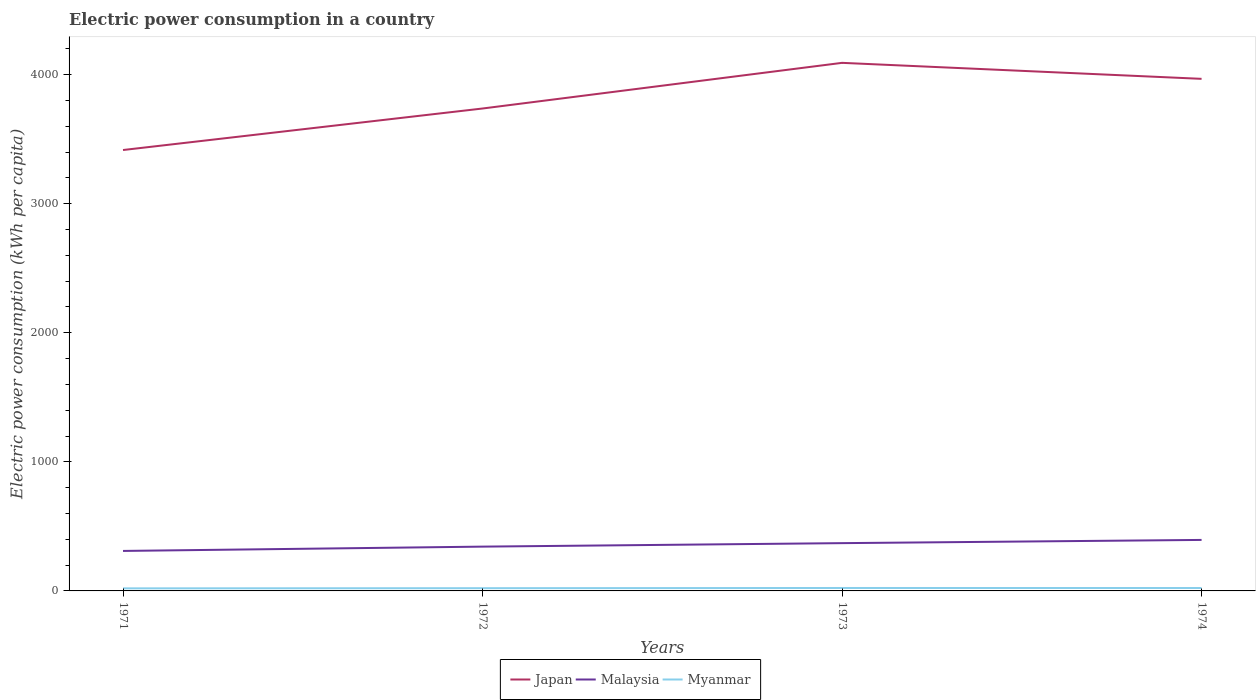How many different coloured lines are there?
Ensure brevity in your answer.  3. Is the number of lines equal to the number of legend labels?
Provide a short and direct response. Yes. Across all years, what is the maximum electric power consumption in in Japan?
Provide a short and direct response. 3415.69. What is the total electric power consumption in in Malaysia in the graph?
Keep it short and to the point. -51.95. What is the difference between the highest and the second highest electric power consumption in in Japan?
Provide a short and direct response. 675.31. What is the difference between the highest and the lowest electric power consumption in in Myanmar?
Your answer should be very brief. 2. How many lines are there?
Keep it short and to the point. 3. How many years are there in the graph?
Offer a very short reply. 4. What is the difference between two consecutive major ticks on the Y-axis?
Keep it short and to the point. 1000. Are the values on the major ticks of Y-axis written in scientific E-notation?
Ensure brevity in your answer.  No. Does the graph contain any zero values?
Your answer should be compact. No. How are the legend labels stacked?
Offer a terse response. Horizontal. What is the title of the graph?
Give a very brief answer. Electric power consumption in a country. Does "Mexico" appear as one of the legend labels in the graph?
Make the answer very short. No. What is the label or title of the Y-axis?
Ensure brevity in your answer.  Electric power consumption (kWh per capita). What is the Electric power consumption (kWh per capita) in Japan in 1971?
Keep it short and to the point. 3415.69. What is the Electric power consumption (kWh per capita) in Malaysia in 1971?
Ensure brevity in your answer.  309.78. What is the Electric power consumption (kWh per capita) of Myanmar in 1971?
Offer a very short reply. 19.87. What is the Electric power consumption (kWh per capita) of Japan in 1972?
Keep it short and to the point. 3737.27. What is the Electric power consumption (kWh per capita) in Malaysia in 1972?
Give a very brief answer. 343.19. What is the Electric power consumption (kWh per capita) in Myanmar in 1972?
Your answer should be compact. 21.22. What is the Electric power consumption (kWh per capita) in Japan in 1973?
Give a very brief answer. 4091. What is the Electric power consumption (kWh per capita) in Malaysia in 1973?
Keep it short and to the point. 370.21. What is the Electric power consumption (kWh per capita) of Myanmar in 1973?
Your answer should be very brief. 22.8. What is the Electric power consumption (kWh per capita) in Japan in 1974?
Make the answer very short. 3967.08. What is the Electric power consumption (kWh per capita) of Malaysia in 1974?
Make the answer very short. 395.15. What is the Electric power consumption (kWh per capita) in Myanmar in 1974?
Offer a very short reply. 22.46. Across all years, what is the maximum Electric power consumption (kWh per capita) of Japan?
Provide a short and direct response. 4091. Across all years, what is the maximum Electric power consumption (kWh per capita) in Malaysia?
Offer a very short reply. 395.15. Across all years, what is the maximum Electric power consumption (kWh per capita) in Myanmar?
Give a very brief answer. 22.8. Across all years, what is the minimum Electric power consumption (kWh per capita) of Japan?
Your answer should be very brief. 3415.69. Across all years, what is the minimum Electric power consumption (kWh per capita) in Malaysia?
Offer a terse response. 309.78. Across all years, what is the minimum Electric power consumption (kWh per capita) of Myanmar?
Keep it short and to the point. 19.87. What is the total Electric power consumption (kWh per capita) in Japan in the graph?
Your answer should be very brief. 1.52e+04. What is the total Electric power consumption (kWh per capita) of Malaysia in the graph?
Give a very brief answer. 1418.33. What is the total Electric power consumption (kWh per capita) of Myanmar in the graph?
Ensure brevity in your answer.  86.34. What is the difference between the Electric power consumption (kWh per capita) of Japan in 1971 and that in 1972?
Offer a terse response. -321.58. What is the difference between the Electric power consumption (kWh per capita) in Malaysia in 1971 and that in 1972?
Make the answer very short. -33.41. What is the difference between the Electric power consumption (kWh per capita) in Myanmar in 1971 and that in 1972?
Give a very brief answer. -1.35. What is the difference between the Electric power consumption (kWh per capita) in Japan in 1971 and that in 1973?
Offer a terse response. -675.31. What is the difference between the Electric power consumption (kWh per capita) of Malaysia in 1971 and that in 1973?
Ensure brevity in your answer.  -60.43. What is the difference between the Electric power consumption (kWh per capita) in Myanmar in 1971 and that in 1973?
Keep it short and to the point. -2.93. What is the difference between the Electric power consumption (kWh per capita) in Japan in 1971 and that in 1974?
Give a very brief answer. -551.4. What is the difference between the Electric power consumption (kWh per capita) in Malaysia in 1971 and that in 1974?
Your answer should be compact. -85.36. What is the difference between the Electric power consumption (kWh per capita) of Myanmar in 1971 and that in 1974?
Your answer should be very brief. -2.6. What is the difference between the Electric power consumption (kWh per capita) in Japan in 1972 and that in 1973?
Your response must be concise. -353.73. What is the difference between the Electric power consumption (kWh per capita) of Malaysia in 1972 and that in 1973?
Provide a short and direct response. -27.02. What is the difference between the Electric power consumption (kWh per capita) in Myanmar in 1972 and that in 1973?
Keep it short and to the point. -1.59. What is the difference between the Electric power consumption (kWh per capita) in Japan in 1972 and that in 1974?
Provide a short and direct response. -229.82. What is the difference between the Electric power consumption (kWh per capita) of Malaysia in 1972 and that in 1974?
Ensure brevity in your answer.  -51.95. What is the difference between the Electric power consumption (kWh per capita) of Myanmar in 1972 and that in 1974?
Make the answer very short. -1.25. What is the difference between the Electric power consumption (kWh per capita) in Japan in 1973 and that in 1974?
Provide a succinct answer. 123.91. What is the difference between the Electric power consumption (kWh per capita) of Malaysia in 1973 and that in 1974?
Provide a succinct answer. -24.93. What is the difference between the Electric power consumption (kWh per capita) of Myanmar in 1973 and that in 1974?
Your answer should be very brief. 0.34. What is the difference between the Electric power consumption (kWh per capita) of Japan in 1971 and the Electric power consumption (kWh per capita) of Malaysia in 1972?
Keep it short and to the point. 3072.5. What is the difference between the Electric power consumption (kWh per capita) in Japan in 1971 and the Electric power consumption (kWh per capita) in Myanmar in 1972?
Offer a terse response. 3394.47. What is the difference between the Electric power consumption (kWh per capita) of Malaysia in 1971 and the Electric power consumption (kWh per capita) of Myanmar in 1972?
Provide a succinct answer. 288.57. What is the difference between the Electric power consumption (kWh per capita) in Japan in 1971 and the Electric power consumption (kWh per capita) in Malaysia in 1973?
Make the answer very short. 3045.47. What is the difference between the Electric power consumption (kWh per capita) of Japan in 1971 and the Electric power consumption (kWh per capita) of Myanmar in 1973?
Your answer should be very brief. 3392.89. What is the difference between the Electric power consumption (kWh per capita) in Malaysia in 1971 and the Electric power consumption (kWh per capita) in Myanmar in 1973?
Keep it short and to the point. 286.98. What is the difference between the Electric power consumption (kWh per capita) of Japan in 1971 and the Electric power consumption (kWh per capita) of Malaysia in 1974?
Give a very brief answer. 3020.54. What is the difference between the Electric power consumption (kWh per capita) in Japan in 1971 and the Electric power consumption (kWh per capita) in Myanmar in 1974?
Offer a very short reply. 3393.23. What is the difference between the Electric power consumption (kWh per capita) of Malaysia in 1971 and the Electric power consumption (kWh per capita) of Myanmar in 1974?
Your response must be concise. 287.32. What is the difference between the Electric power consumption (kWh per capita) in Japan in 1972 and the Electric power consumption (kWh per capita) in Malaysia in 1973?
Your answer should be very brief. 3367.05. What is the difference between the Electric power consumption (kWh per capita) in Japan in 1972 and the Electric power consumption (kWh per capita) in Myanmar in 1973?
Provide a short and direct response. 3714.46. What is the difference between the Electric power consumption (kWh per capita) in Malaysia in 1972 and the Electric power consumption (kWh per capita) in Myanmar in 1973?
Your response must be concise. 320.39. What is the difference between the Electric power consumption (kWh per capita) of Japan in 1972 and the Electric power consumption (kWh per capita) of Malaysia in 1974?
Keep it short and to the point. 3342.12. What is the difference between the Electric power consumption (kWh per capita) of Japan in 1972 and the Electric power consumption (kWh per capita) of Myanmar in 1974?
Your answer should be compact. 3714.8. What is the difference between the Electric power consumption (kWh per capita) of Malaysia in 1972 and the Electric power consumption (kWh per capita) of Myanmar in 1974?
Your answer should be compact. 320.73. What is the difference between the Electric power consumption (kWh per capita) of Japan in 1973 and the Electric power consumption (kWh per capita) of Malaysia in 1974?
Offer a terse response. 3695.85. What is the difference between the Electric power consumption (kWh per capita) in Japan in 1973 and the Electric power consumption (kWh per capita) in Myanmar in 1974?
Offer a very short reply. 4068.54. What is the difference between the Electric power consumption (kWh per capita) of Malaysia in 1973 and the Electric power consumption (kWh per capita) of Myanmar in 1974?
Provide a short and direct response. 347.75. What is the average Electric power consumption (kWh per capita) of Japan per year?
Ensure brevity in your answer.  3802.76. What is the average Electric power consumption (kWh per capita) in Malaysia per year?
Give a very brief answer. 354.58. What is the average Electric power consumption (kWh per capita) in Myanmar per year?
Offer a very short reply. 21.59. In the year 1971, what is the difference between the Electric power consumption (kWh per capita) of Japan and Electric power consumption (kWh per capita) of Malaysia?
Your answer should be very brief. 3105.91. In the year 1971, what is the difference between the Electric power consumption (kWh per capita) of Japan and Electric power consumption (kWh per capita) of Myanmar?
Provide a succinct answer. 3395.82. In the year 1971, what is the difference between the Electric power consumption (kWh per capita) in Malaysia and Electric power consumption (kWh per capita) in Myanmar?
Keep it short and to the point. 289.92. In the year 1972, what is the difference between the Electric power consumption (kWh per capita) in Japan and Electric power consumption (kWh per capita) in Malaysia?
Offer a terse response. 3394.07. In the year 1972, what is the difference between the Electric power consumption (kWh per capita) in Japan and Electric power consumption (kWh per capita) in Myanmar?
Keep it short and to the point. 3716.05. In the year 1972, what is the difference between the Electric power consumption (kWh per capita) in Malaysia and Electric power consumption (kWh per capita) in Myanmar?
Ensure brevity in your answer.  321.98. In the year 1973, what is the difference between the Electric power consumption (kWh per capita) in Japan and Electric power consumption (kWh per capita) in Malaysia?
Provide a short and direct response. 3720.78. In the year 1973, what is the difference between the Electric power consumption (kWh per capita) of Japan and Electric power consumption (kWh per capita) of Myanmar?
Provide a succinct answer. 4068.2. In the year 1973, what is the difference between the Electric power consumption (kWh per capita) of Malaysia and Electric power consumption (kWh per capita) of Myanmar?
Offer a very short reply. 347.41. In the year 1974, what is the difference between the Electric power consumption (kWh per capita) of Japan and Electric power consumption (kWh per capita) of Malaysia?
Make the answer very short. 3571.94. In the year 1974, what is the difference between the Electric power consumption (kWh per capita) in Japan and Electric power consumption (kWh per capita) in Myanmar?
Offer a very short reply. 3944.62. In the year 1974, what is the difference between the Electric power consumption (kWh per capita) in Malaysia and Electric power consumption (kWh per capita) in Myanmar?
Give a very brief answer. 372.68. What is the ratio of the Electric power consumption (kWh per capita) in Japan in 1971 to that in 1972?
Your answer should be compact. 0.91. What is the ratio of the Electric power consumption (kWh per capita) in Malaysia in 1971 to that in 1972?
Make the answer very short. 0.9. What is the ratio of the Electric power consumption (kWh per capita) of Myanmar in 1971 to that in 1972?
Keep it short and to the point. 0.94. What is the ratio of the Electric power consumption (kWh per capita) in Japan in 1971 to that in 1973?
Your response must be concise. 0.83. What is the ratio of the Electric power consumption (kWh per capita) in Malaysia in 1971 to that in 1973?
Make the answer very short. 0.84. What is the ratio of the Electric power consumption (kWh per capita) in Myanmar in 1971 to that in 1973?
Provide a succinct answer. 0.87. What is the ratio of the Electric power consumption (kWh per capita) in Japan in 1971 to that in 1974?
Your response must be concise. 0.86. What is the ratio of the Electric power consumption (kWh per capita) in Malaysia in 1971 to that in 1974?
Your answer should be very brief. 0.78. What is the ratio of the Electric power consumption (kWh per capita) of Myanmar in 1971 to that in 1974?
Make the answer very short. 0.88. What is the ratio of the Electric power consumption (kWh per capita) in Japan in 1972 to that in 1973?
Make the answer very short. 0.91. What is the ratio of the Electric power consumption (kWh per capita) of Malaysia in 1972 to that in 1973?
Your response must be concise. 0.93. What is the ratio of the Electric power consumption (kWh per capita) in Myanmar in 1972 to that in 1973?
Provide a succinct answer. 0.93. What is the ratio of the Electric power consumption (kWh per capita) of Japan in 1972 to that in 1974?
Provide a succinct answer. 0.94. What is the ratio of the Electric power consumption (kWh per capita) in Malaysia in 1972 to that in 1974?
Your answer should be very brief. 0.87. What is the ratio of the Electric power consumption (kWh per capita) in Myanmar in 1972 to that in 1974?
Offer a terse response. 0.94. What is the ratio of the Electric power consumption (kWh per capita) in Japan in 1973 to that in 1974?
Ensure brevity in your answer.  1.03. What is the ratio of the Electric power consumption (kWh per capita) in Malaysia in 1973 to that in 1974?
Provide a succinct answer. 0.94. What is the ratio of the Electric power consumption (kWh per capita) of Myanmar in 1973 to that in 1974?
Provide a short and direct response. 1.02. What is the difference between the highest and the second highest Electric power consumption (kWh per capita) in Japan?
Make the answer very short. 123.91. What is the difference between the highest and the second highest Electric power consumption (kWh per capita) of Malaysia?
Offer a very short reply. 24.93. What is the difference between the highest and the second highest Electric power consumption (kWh per capita) of Myanmar?
Give a very brief answer. 0.34. What is the difference between the highest and the lowest Electric power consumption (kWh per capita) in Japan?
Offer a very short reply. 675.31. What is the difference between the highest and the lowest Electric power consumption (kWh per capita) in Malaysia?
Your response must be concise. 85.36. What is the difference between the highest and the lowest Electric power consumption (kWh per capita) in Myanmar?
Offer a very short reply. 2.93. 